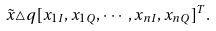<formula> <loc_0><loc_0><loc_500><loc_500>\tilde { x } \triangle q [ x _ { 1 I } , x _ { 1 Q } , \cdots , x _ { n I } , x _ { n Q } ] ^ { T } .</formula> 